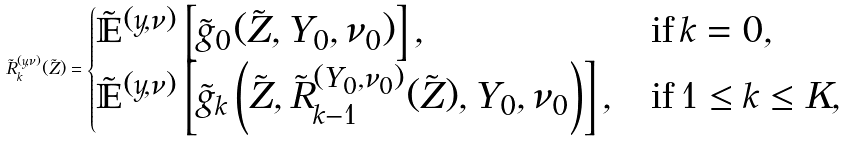Convert formula to latex. <formula><loc_0><loc_0><loc_500><loc_500>\tilde { R } _ { k } ^ { ( y , \nu ) } ( \tilde { Z } ) = \begin{cases} \tilde { \mathbb { E } } ^ { ( y , \nu ) } \left [ \tilde { g } _ { 0 } ( \tilde { Z } , Y _ { 0 } , \nu _ { 0 } ) \right ] , & \text {if} \, k = 0 , \\ \tilde { \mathbb { E } } ^ { ( y , \nu ) } \left [ \tilde { g } _ { k } \left ( \tilde { Z } , \tilde { R } _ { k - 1 } ^ { ( Y _ { 0 } , \nu _ { 0 } ) } ( \tilde { Z } ) , Y _ { 0 } , \nu _ { 0 } \right ) \right ] , & \text {if} \, 1 \leq k \leq K , \end{cases}</formula> 